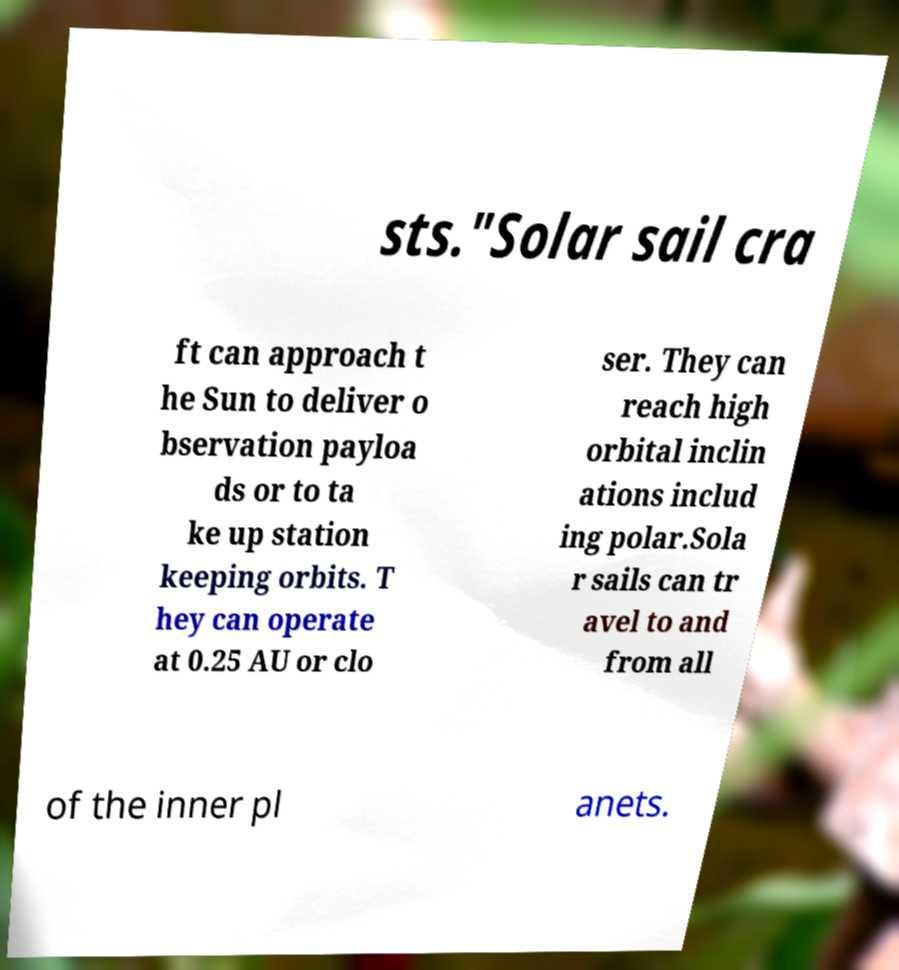Can you accurately transcribe the text from the provided image for me? sts."Solar sail cra ft can approach t he Sun to deliver o bservation payloa ds or to ta ke up station keeping orbits. T hey can operate at 0.25 AU or clo ser. They can reach high orbital inclin ations includ ing polar.Sola r sails can tr avel to and from all of the inner pl anets. 